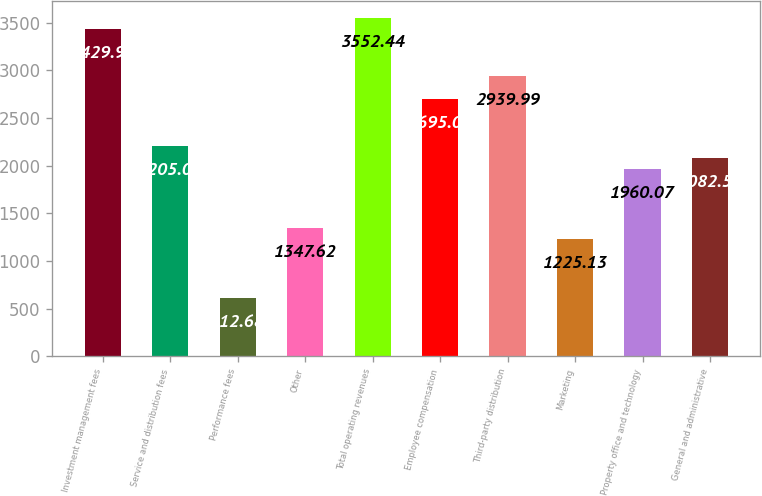Convert chart to OTSL. <chart><loc_0><loc_0><loc_500><loc_500><bar_chart><fcel>Investment management fees<fcel>Service and distribution fees<fcel>Performance fees<fcel>Other<fcel>Total operating revenues<fcel>Employee compensation<fcel>Third-party distribution<fcel>Marketing<fcel>Property office and technology<fcel>General and administrative<nl><fcel>3429.95<fcel>2205.05<fcel>612.68<fcel>1347.62<fcel>3552.44<fcel>2695.01<fcel>2939.99<fcel>1225.13<fcel>1960.07<fcel>2082.56<nl></chart> 